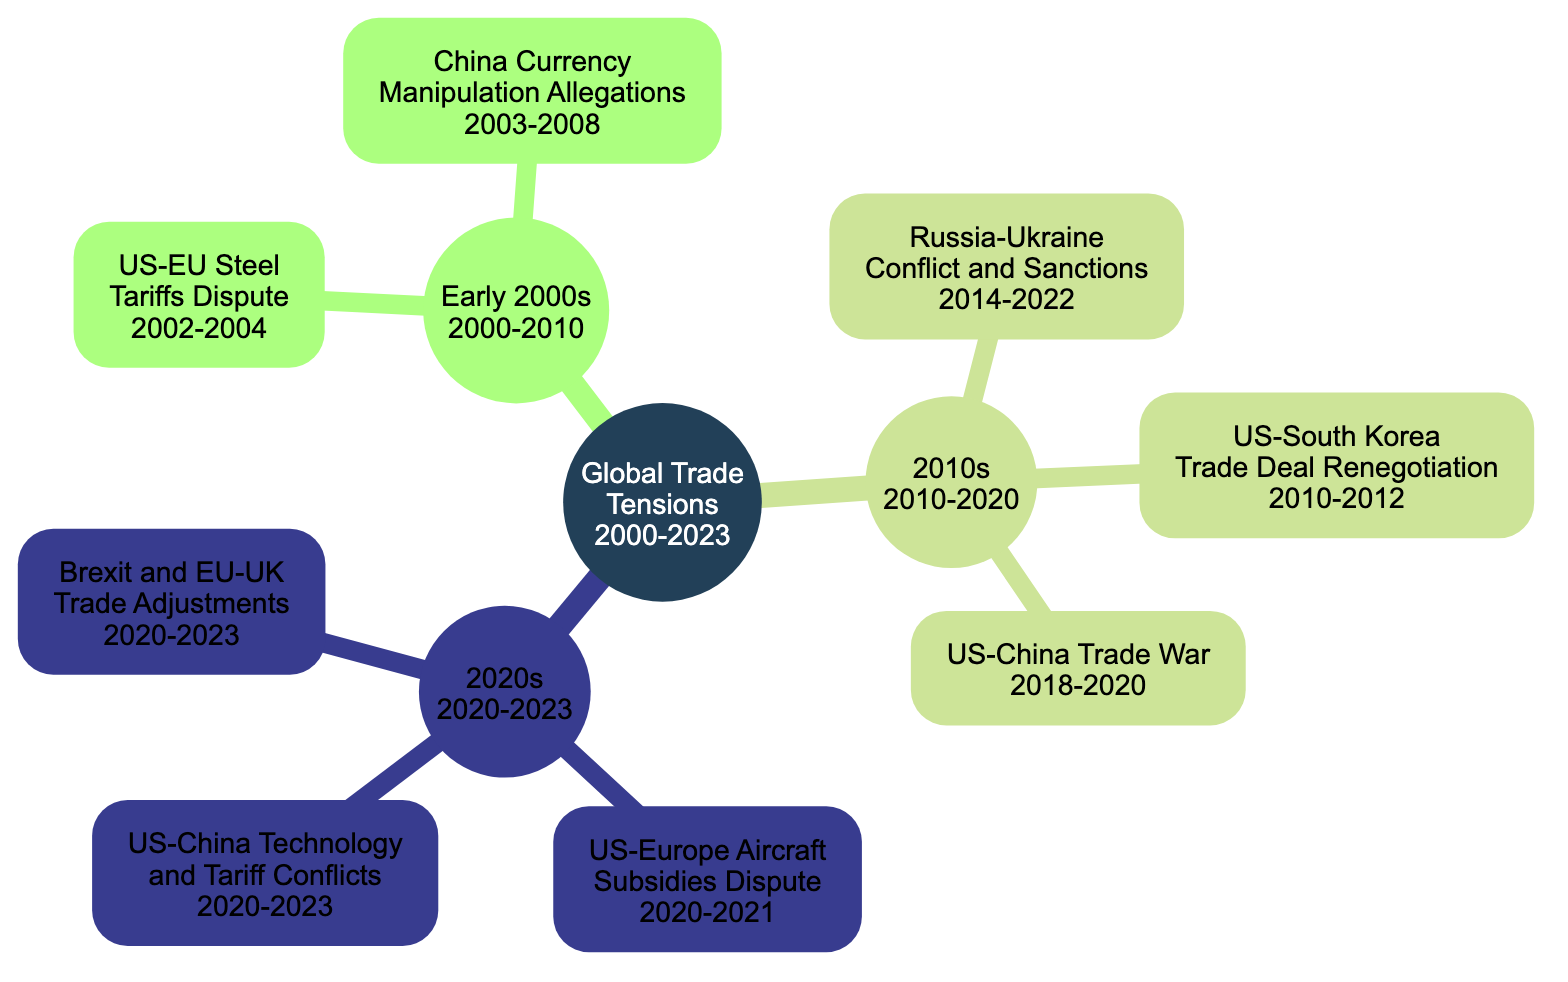What is the starting year of the "Global Trade Tensions"? The diagram shows that the starting year of the main node "Global Trade Tensions" is labeled as 2000.
Answer: 2000 How many major trade conflicts are listed in the "2010s" section? In the "2010s" section, there are three trade conflicts listed: the US-South Korea Trade Deal Renegotiation, Russia-Ukraine Conflict and Sanctions, and US-China Trade War. Therefore, the total count is three.
Answer: 3 What year did the US-EU Steel Tariffs Dispute begin? The diagram indicates that the US-EU Steel Tariffs Dispute began in the year 2002.
Answer: 2002 Which conflict spans the longest time in the diagram? By examining the time periods of each listed conflict, the Russia-Ukraine Conflict and Sanctions spans from 2014 to 2022, which is a total of eight years, making it the longest conflict in the diagram.
Answer: Russia-Ukraine Conflict and Sanctions What are the three conflicts depicted in the "2020s" section? The diagram lists three conflicts in the "2020s" section: US-Europe Aircraft Subsidies Dispute (2020-2021), US-China Technology and Tariff Conflicts (2020-2023), and Brexit and EU-UK Trade Adjustments (2020-2023).
Answer: US-Europe Aircraft Subsidies Dispute, US-China Technology and Tariff Conflicts, Brexit and EU-UK Trade Adjustments How many years does the US-China Trade War last? The diagram shows that the US-China Trade War started in 2018 and ended in 2020, lasting for two years.
Answer: 2 Are there any trade conflicts that began before 2005? Yes, the US-EU Steel Tariffs Dispute (2002-2004) and the China Currency Manipulation Allegations (2003-2008) are both conflicts that started before 2005.
Answer: Yes What is the main node of the diagram? The main node of the diagram is labeled "Global Trade Tensions".
Answer: Global Trade Tensions 